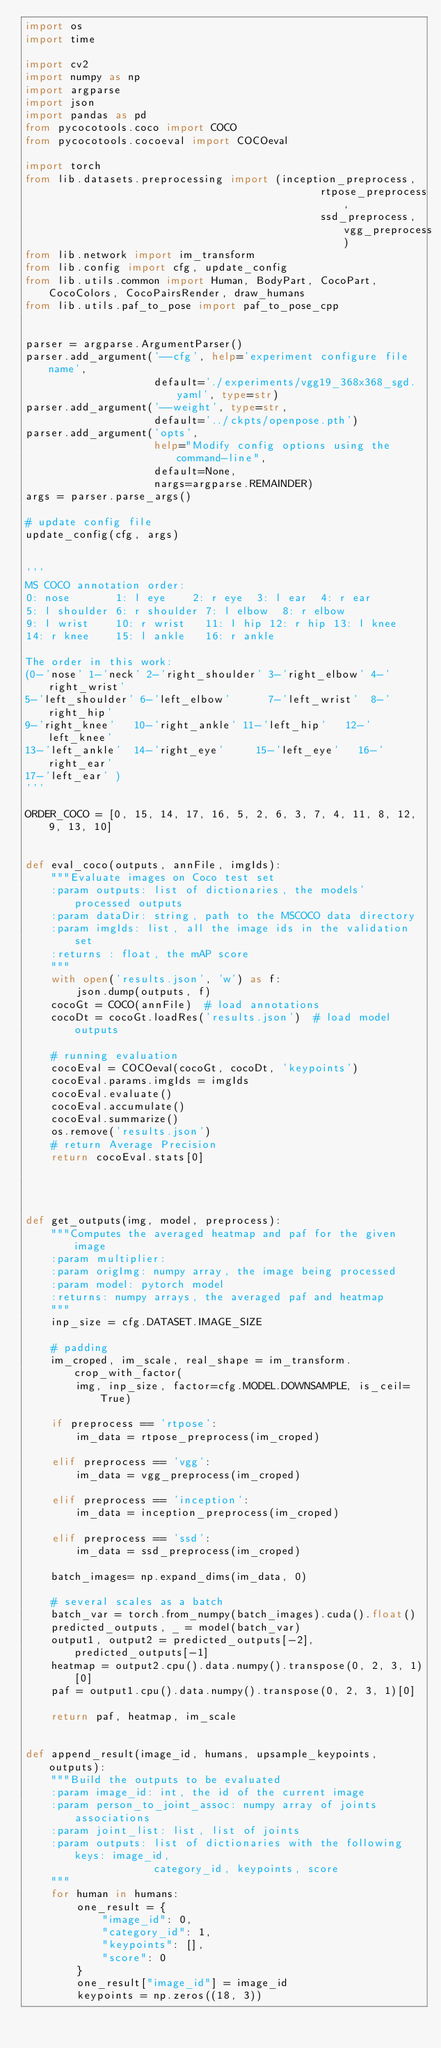Convert code to text. <code><loc_0><loc_0><loc_500><loc_500><_Python_>import os
import time

import cv2
import numpy as np
import argparse
import json
import pandas as pd
from pycocotools.coco import COCO
from pycocotools.cocoeval import COCOeval

import torch
from lib.datasets.preprocessing import (inception_preprocess,
                                              rtpose_preprocess,
                                              ssd_preprocess, vgg_preprocess)
from lib.network import im_transform                                              
from lib.config import cfg, update_config
from lib.utils.common import Human, BodyPart, CocoPart, CocoColors, CocoPairsRender, draw_humans
from lib.utils.paf_to_pose import paf_to_pose_cpp


parser = argparse.ArgumentParser()
parser.add_argument('--cfg', help='experiment configure file name',
                    default='./experiments/vgg19_368x368_sgd.yaml', type=str)
parser.add_argument('--weight', type=str,
                    default='../ckpts/openpose.pth')
parser.add_argument('opts',
                    help="Modify config options using the command-line",
                    default=None,
                    nargs=argparse.REMAINDER)
args = parser.parse_args()

# update config file
update_config(cfg, args)


'''
MS COCO annotation order:
0: nose	   		1: l eye		2: r eye	3: l ear	4: r ear
5: l shoulder	6: r shoulder	7: l elbow	8: r elbow
9: l wrist		10: r wrist		11: l hip	12: r hip	13: l knee
14: r knee		15: l ankle		16: r ankle

The order in this work:
(0-'nose'	1-'neck' 2-'right_shoulder' 3-'right_elbow' 4-'right_wrist'
5-'left_shoulder' 6-'left_elbow'	    7-'left_wrist'  8-'right_hip'
9-'right_knee'	 10-'right_ankle'	11-'left_hip'   12-'left_knee'
13-'left_ankle'	 14-'right_eye'	    15-'left_eye'   16-'right_ear'
17-'left_ear' )
'''

ORDER_COCO = [0, 15, 14, 17, 16, 5, 2, 6, 3, 7, 4, 11, 8, 12, 9, 13, 10]


def eval_coco(outputs, annFile, imgIds):
    """Evaluate images on Coco test set
    :param outputs: list of dictionaries, the models' processed outputs
    :param dataDir: string, path to the MSCOCO data directory
    :param imgIds: list, all the image ids in the validation set
    :returns : float, the mAP score
    """
    with open('results.json', 'w') as f:
        json.dump(outputs, f)  
    cocoGt = COCO(annFile)  # load annotations
    cocoDt = cocoGt.loadRes('results.json')  # load model outputs

    # running evaluation
    cocoEval = COCOeval(cocoGt, cocoDt, 'keypoints')
    cocoEval.params.imgIds = imgIds
    cocoEval.evaluate()
    cocoEval.accumulate()
    cocoEval.summarize()
    os.remove('results.json')
    # return Average Precision
    return cocoEval.stats[0]




def get_outputs(img, model, preprocess):
    """Computes the averaged heatmap and paf for the given image
    :param multiplier:
    :param origImg: numpy array, the image being processed
    :param model: pytorch model
    :returns: numpy arrays, the averaged paf and heatmap
    """
    inp_size = cfg.DATASET.IMAGE_SIZE

    # padding
    im_croped, im_scale, real_shape = im_transform.crop_with_factor(
        img, inp_size, factor=cfg.MODEL.DOWNSAMPLE, is_ceil=True)

    if preprocess == 'rtpose':
        im_data = rtpose_preprocess(im_croped)

    elif preprocess == 'vgg':
        im_data = vgg_preprocess(im_croped)

    elif preprocess == 'inception':
        im_data = inception_preprocess(im_croped)

    elif preprocess == 'ssd':
        im_data = ssd_preprocess(im_croped)

    batch_images= np.expand_dims(im_data, 0)

    # several scales as a batch
    batch_var = torch.from_numpy(batch_images).cuda().float()
    predicted_outputs, _ = model(batch_var)
    output1, output2 = predicted_outputs[-2], predicted_outputs[-1]
    heatmap = output2.cpu().data.numpy().transpose(0, 2, 3, 1)[0]
    paf = output1.cpu().data.numpy().transpose(0, 2, 3, 1)[0]

    return paf, heatmap, im_scale


def append_result(image_id, humans, upsample_keypoints, outputs):
    """Build the outputs to be evaluated
    :param image_id: int, the id of the current image
    :param person_to_joint_assoc: numpy array of joints associations
    :param joint_list: list, list of joints
    :param outputs: list of dictionaries with the following keys: image_id,
                    category_id, keypoints, score
    """ 
    for human in humans:
        one_result = {
            "image_id": 0,
            "category_id": 1,
            "keypoints": [],
            "score": 0
        }
        one_result["image_id"] = image_id
        keypoints = np.zeros((18, 3))       
        </code> 